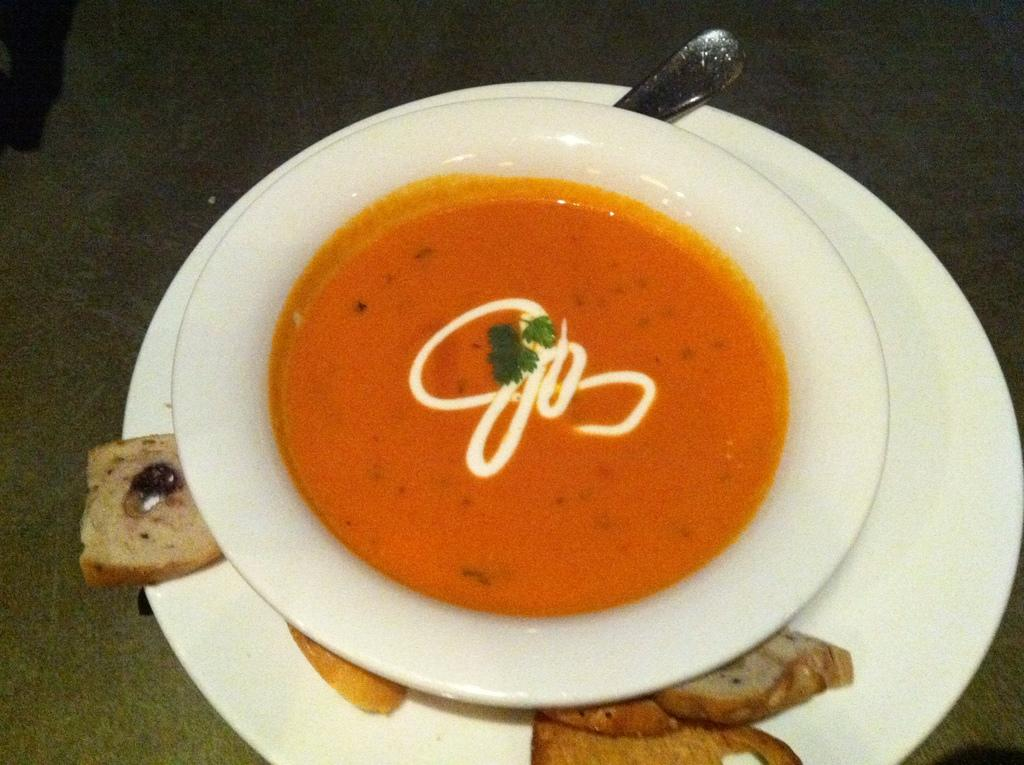What is on the plate in the image? There is a bowl on a plate in the image. What is inside the bowl? There is food in the bowl. What utensil is present on the table in the image? There is a spoon on the table in the image. What type of dress is the food wearing in the image? The food in the bowl is not wearing a dress; it is simply food inside a bowl. How many buttons can be seen on the spoon in the image? There are no buttons present on the spoon in the image, as spoons do not have buttons. 